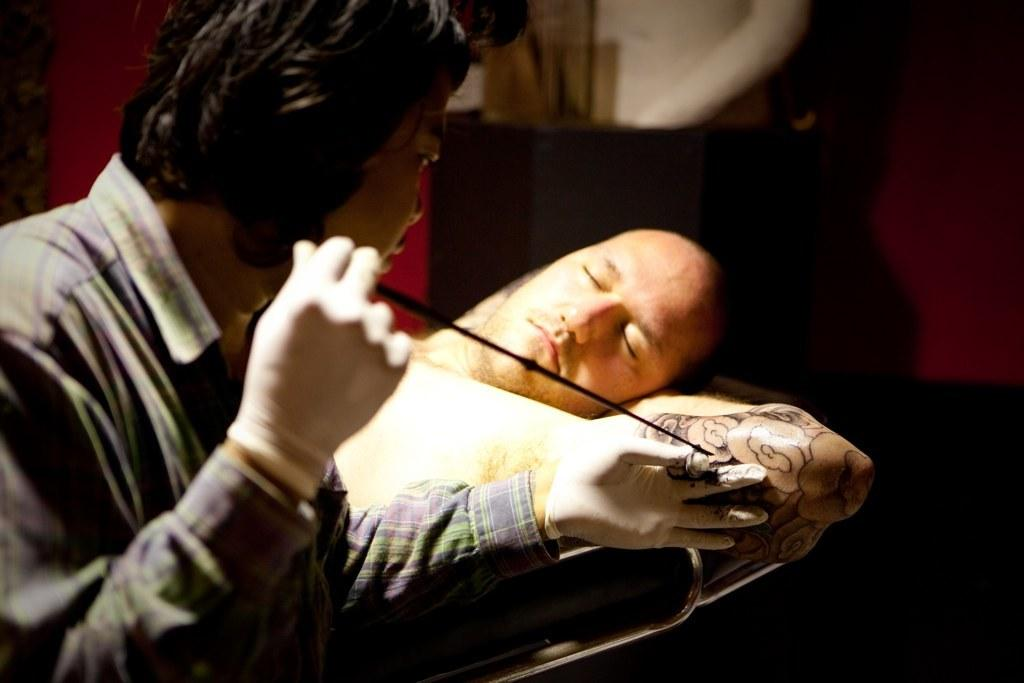What is the position of the person in the image? There is a person lying down in the image. What is the other person in the image doing? The other person is holding an object in the image. What is the nature of the object being held? The object appears to be a tattoo on a person's hand. Can you describe the background of the image? There is an object visible in the background of the image. What type of cloth is being offered to the person lying down in the image? There is no cloth being offered in the image. 